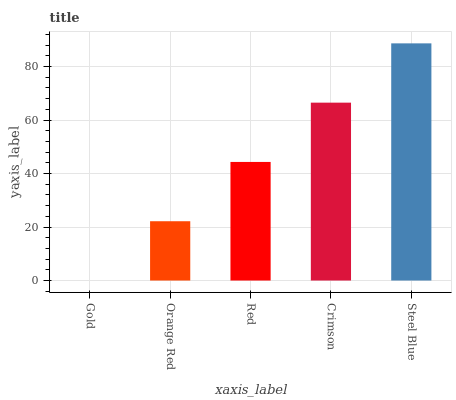Is Gold the minimum?
Answer yes or no. Yes. Is Steel Blue the maximum?
Answer yes or no. Yes. Is Orange Red the minimum?
Answer yes or no. No. Is Orange Red the maximum?
Answer yes or no. No. Is Orange Red greater than Gold?
Answer yes or no. Yes. Is Gold less than Orange Red?
Answer yes or no. Yes. Is Gold greater than Orange Red?
Answer yes or no. No. Is Orange Red less than Gold?
Answer yes or no. No. Is Red the high median?
Answer yes or no. Yes. Is Red the low median?
Answer yes or no. Yes. Is Crimson the high median?
Answer yes or no. No. Is Gold the low median?
Answer yes or no. No. 